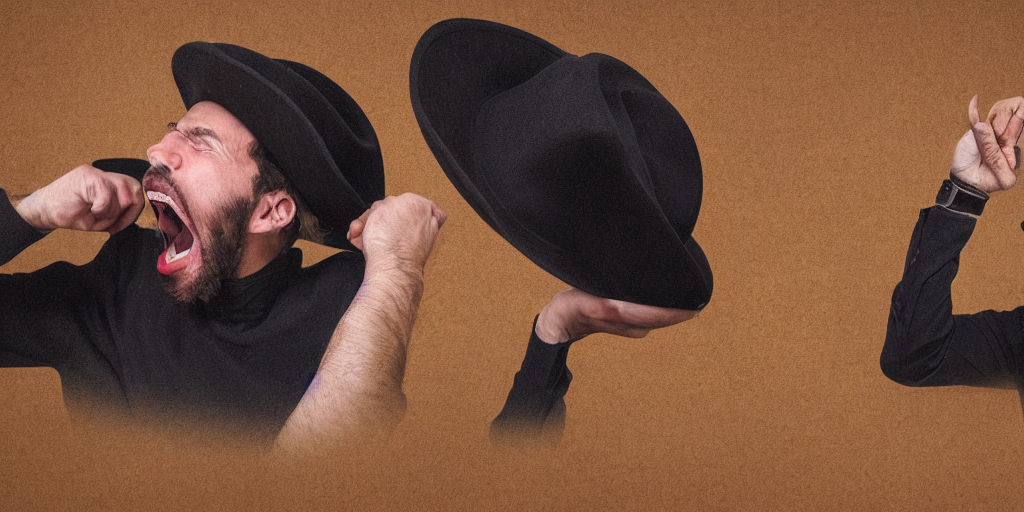Are there any quality issues with this image? Upon closer examination, the image appears to be of high quality; however, the nature of the content raises questions about the intent of the composition. The image features a creative concept, likely representing an internal struggle or loud expression presented in a playful, surreal manner. 